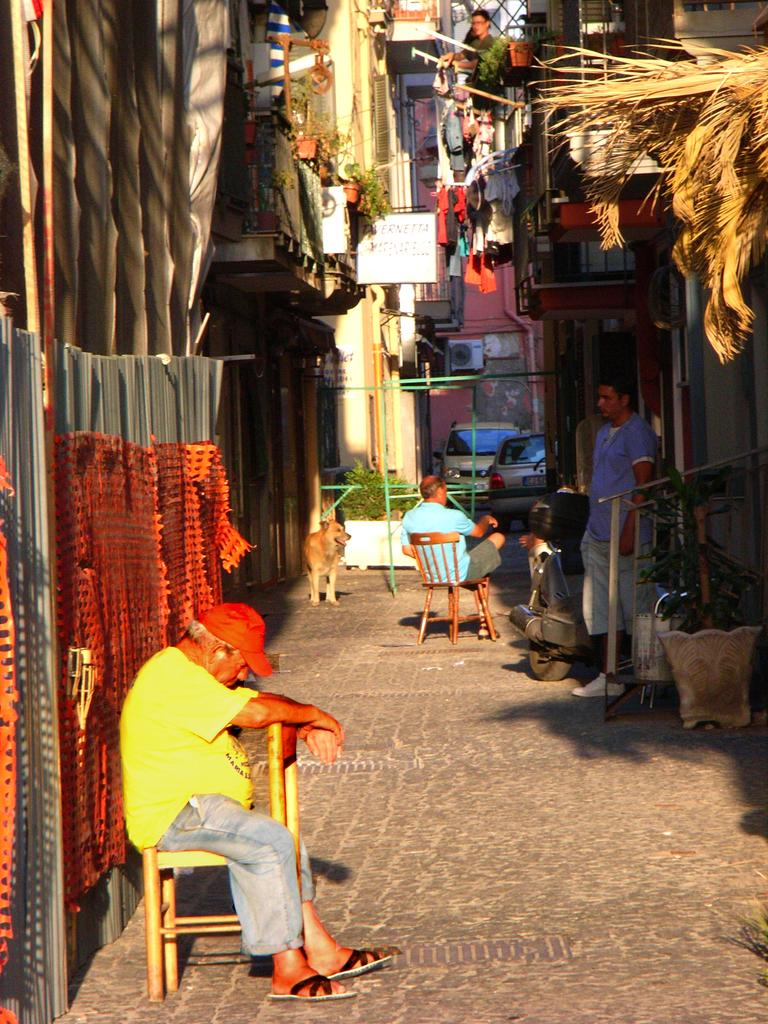What type of structures can be seen in the image? There are buildings in the image. What else is present in the image besides buildings? There are plants, a road, chairs, and two people sitting on the chairs. Can you describe the road in the image? There is a road in the image, and a dog is on the road. What type of seating is visible in the image? Chairs are visible in the image, and two people are sitting on them. What impulse does the sky have in the image? There is no mention of a sky or any impulse in the image; it features buildings, plants, a road, chairs, and two people sitting on the chairs. What is on the top of the buildings in the image? The provided facts do not mention anything on top of the buildings, so we cannot answer this question definitively. 